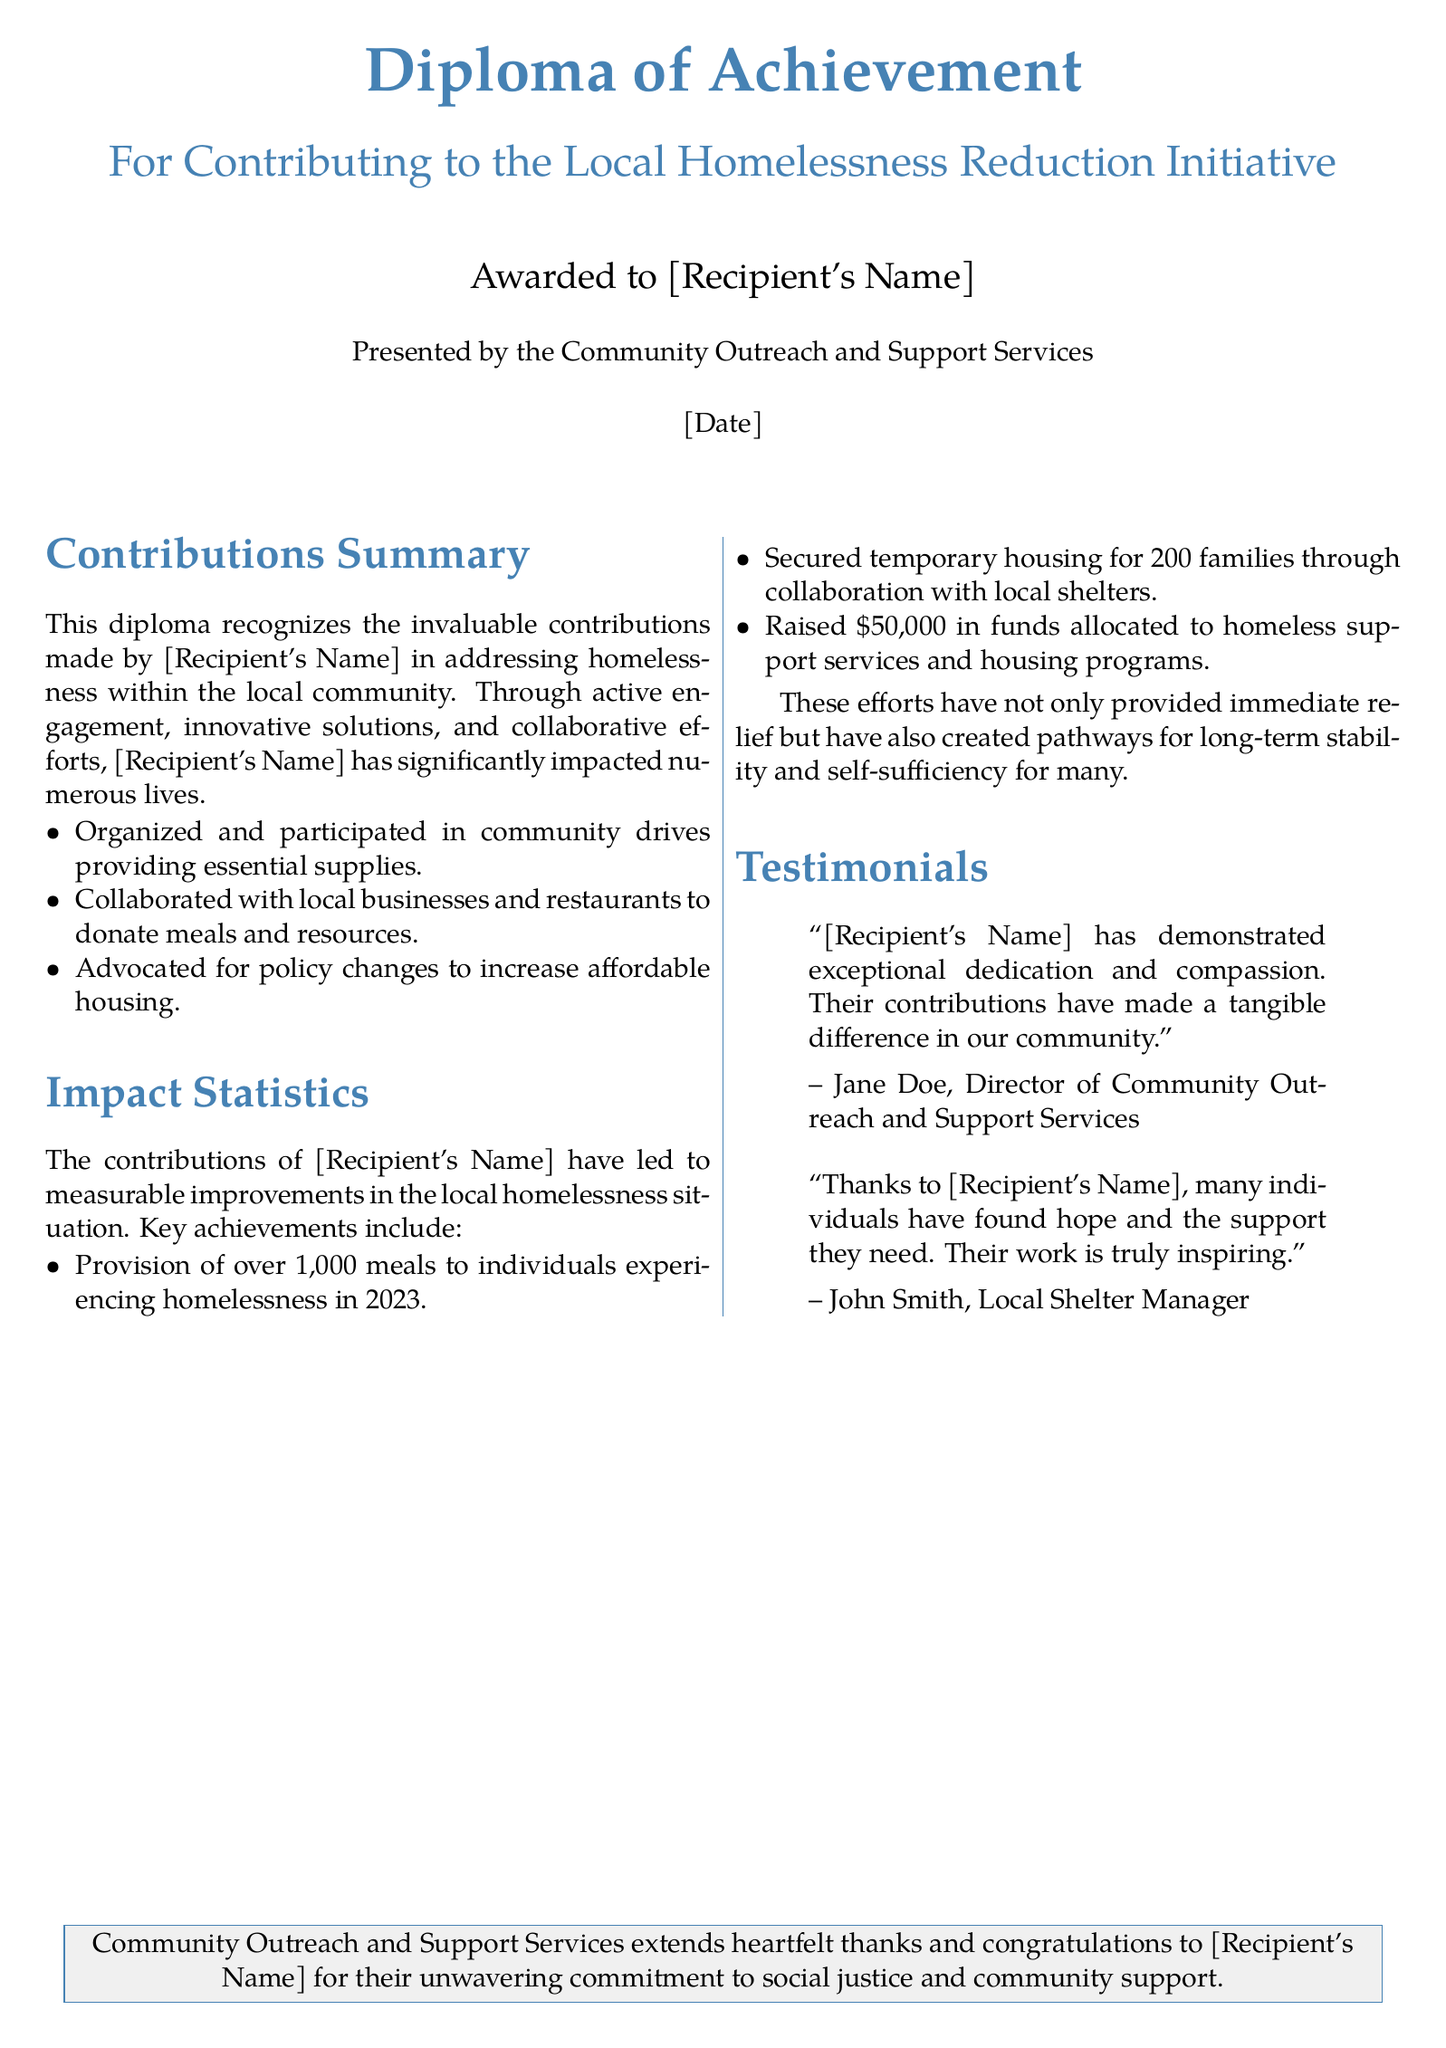What is the title of the diploma? The title of the diploma is prominently displayed at the top of the document.
Answer: Diploma of Achievement Who awarded the diploma? The awarding body is mentioned below the recipient's name.
Answer: Community Outreach and Support Services What year did the recipient provide meals to individuals experiencing homelessness? The year is specified in the section discussing impact statistics.
Answer: 2023 How many families secured temporary housing through contributions? This number is mentioned in the impact statistics section.
Answer: 200 families How much money was raised for homeless support services? The total amount is indicated in the impact statistics section.
Answer: \$50,000 Who is a testimonial provider that praised [Recipient's Name]? The name of the testimonial provider is included in the testimonials section.
Answer: Jane Doe What specific initiative does the diploma recognize contributions towards? The initiative is described in the subtitle of the diploma.
Answer: Local Homelessness Reduction Initiative What does the diploma extend to the recipient? The final section highlights the document's closing statement.
Answer: Heartfelt thanks and congratulations 